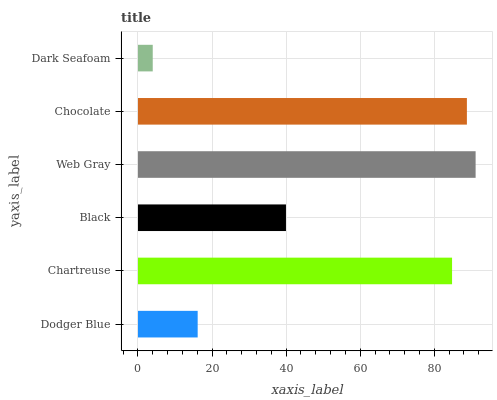Is Dark Seafoam the minimum?
Answer yes or no. Yes. Is Web Gray the maximum?
Answer yes or no. Yes. Is Chartreuse the minimum?
Answer yes or no. No. Is Chartreuse the maximum?
Answer yes or no. No. Is Chartreuse greater than Dodger Blue?
Answer yes or no. Yes. Is Dodger Blue less than Chartreuse?
Answer yes or no. Yes. Is Dodger Blue greater than Chartreuse?
Answer yes or no. No. Is Chartreuse less than Dodger Blue?
Answer yes or no. No. Is Chartreuse the high median?
Answer yes or no. Yes. Is Black the low median?
Answer yes or no. Yes. Is Black the high median?
Answer yes or no. No. Is Dark Seafoam the low median?
Answer yes or no. No. 